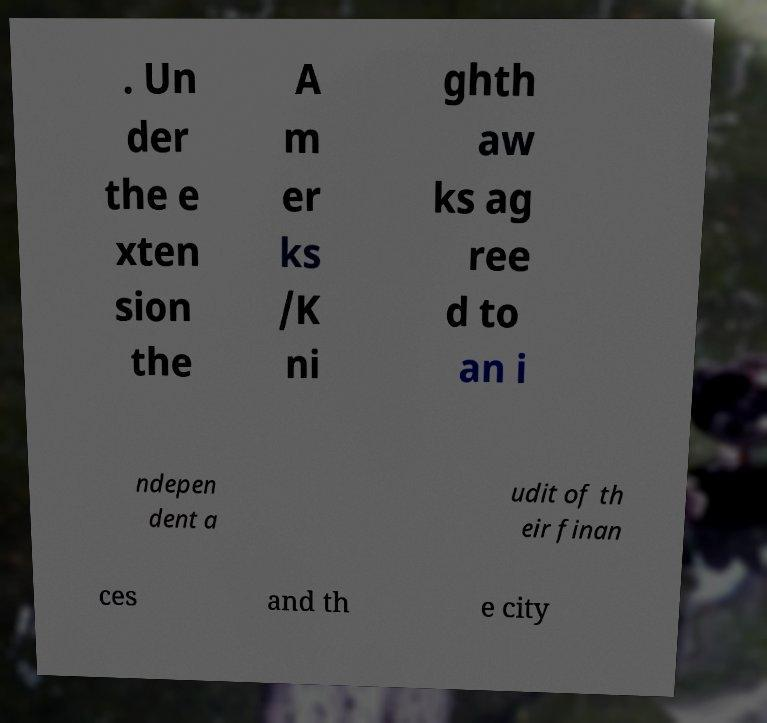Please read and relay the text visible in this image. What does it say? . Un der the e xten sion the A m er ks /K ni ghth aw ks ag ree d to an i ndepen dent a udit of th eir finan ces and th e city 